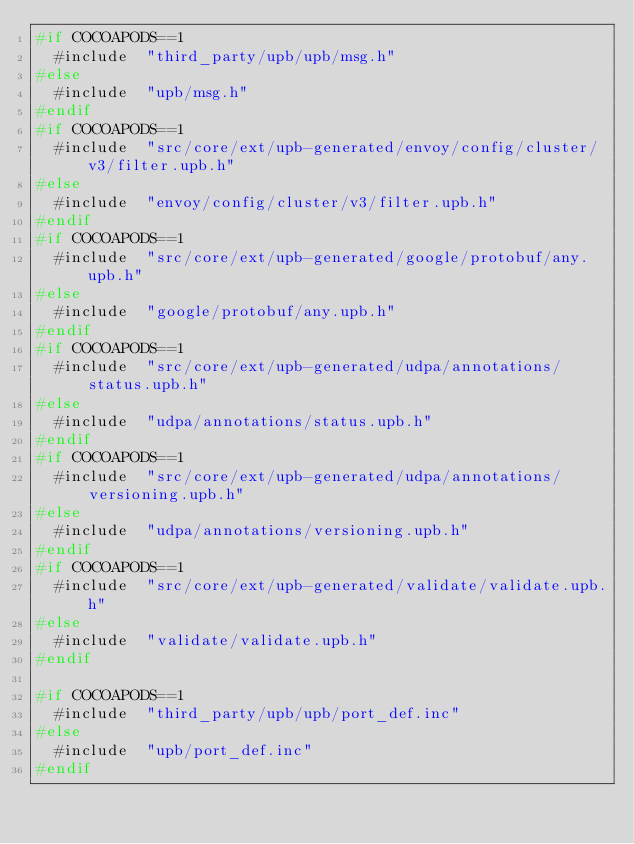<code> <loc_0><loc_0><loc_500><loc_500><_C_>#if COCOAPODS==1
  #include  "third_party/upb/upb/msg.h"
#else
  #include  "upb/msg.h"
#endif
#if COCOAPODS==1
  #include  "src/core/ext/upb-generated/envoy/config/cluster/v3/filter.upb.h"
#else
  #include  "envoy/config/cluster/v3/filter.upb.h"
#endif
#if COCOAPODS==1
  #include  "src/core/ext/upb-generated/google/protobuf/any.upb.h"
#else
  #include  "google/protobuf/any.upb.h"
#endif
#if COCOAPODS==1
  #include  "src/core/ext/upb-generated/udpa/annotations/status.upb.h"
#else
  #include  "udpa/annotations/status.upb.h"
#endif
#if COCOAPODS==1
  #include  "src/core/ext/upb-generated/udpa/annotations/versioning.upb.h"
#else
  #include  "udpa/annotations/versioning.upb.h"
#endif
#if COCOAPODS==1
  #include  "src/core/ext/upb-generated/validate/validate.upb.h"
#else
  #include  "validate/validate.upb.h"
#endif

#if COCOAPODS==1
  #include  "third_party/upb/upb/port_def.inc"
#else
  #include  "upb/port_def.inc"
#endif
</code> 